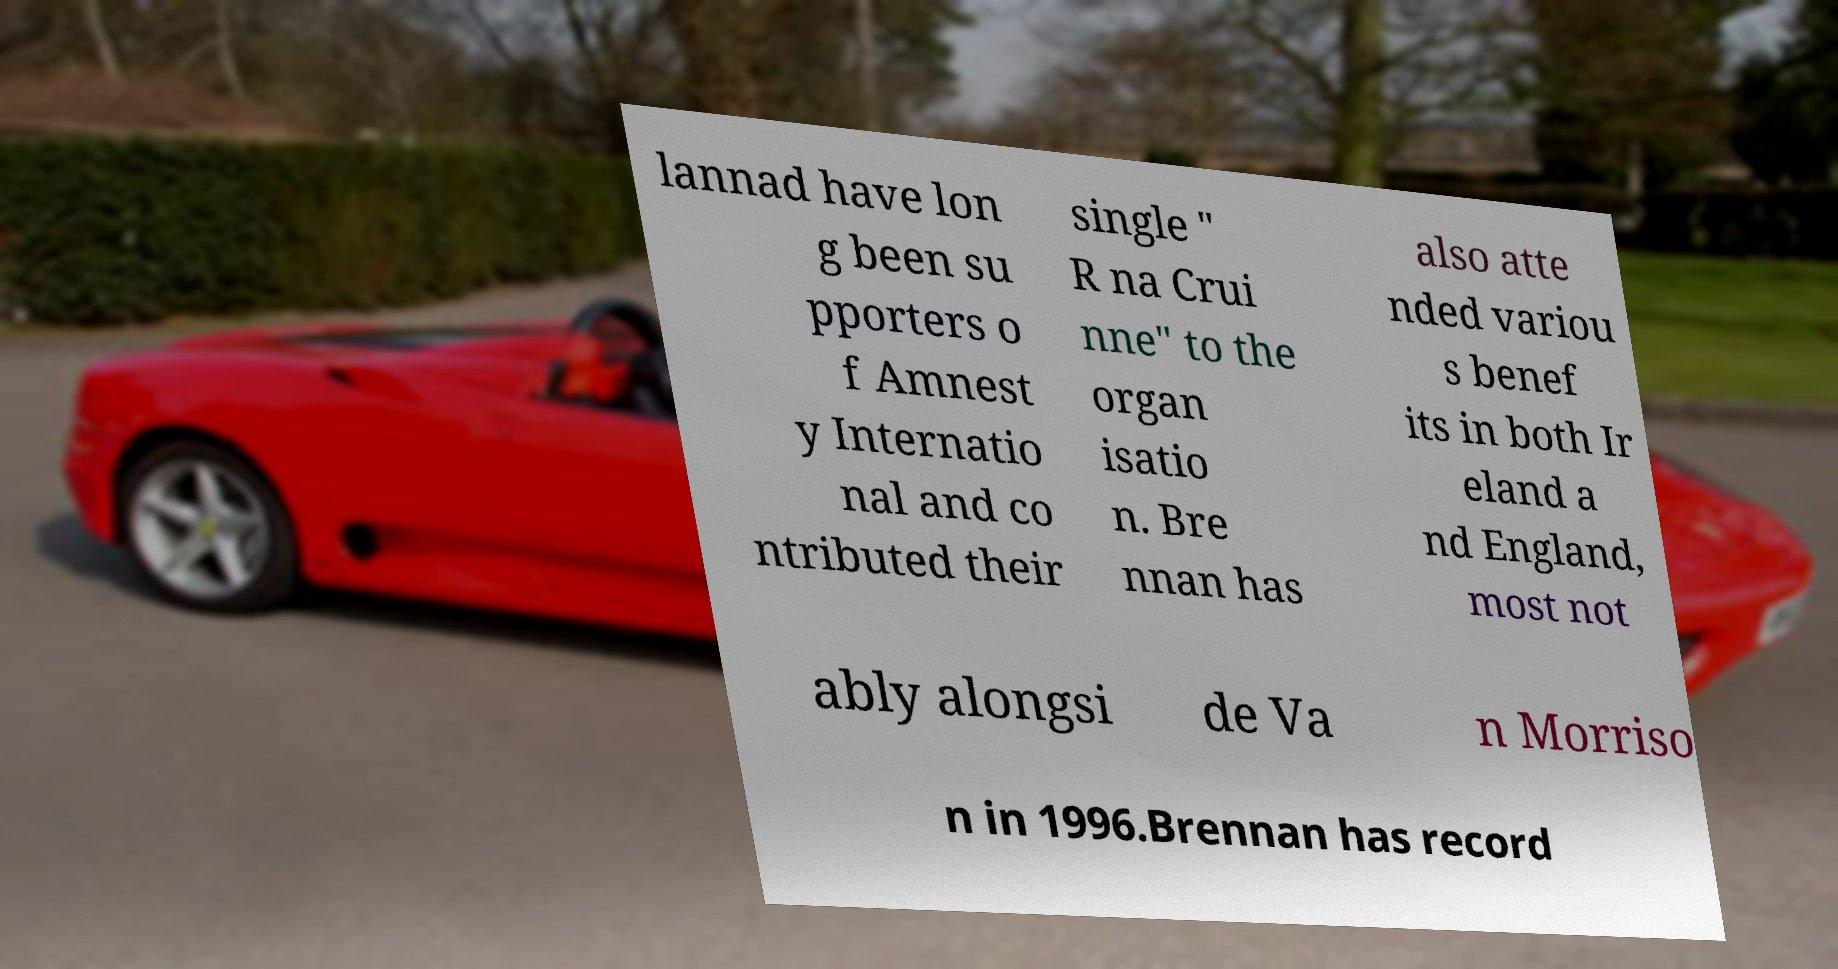There's text embedded in this image that I need extracted. Can you transcribe it verbatim? lannad have lon g been su pporters o f Amnest y Internatio nal and co ntributed their single " R na Crui nne" to the organ isatio n. Bre nnan has also atte nded variou s benef its in both Ir eland a nd England, most not ably alongsi de Va n Morriso n in 1996.Brennan has record 